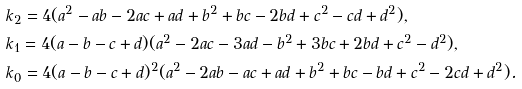Convert formula to latex. <formula><loc_0><loc_0><loc_500><loc_500>& k _ { 2 } = 4 ( a ^ { 2 } - a b - 2 a c + a d + b ^ { 2 } + b c - 2 b d + c ^ { 2 } - c d + d ^ { 2 } ) , \\ & k _ { 1 } = 4 ( a - b - c + d ) ( a ^ { 2 } - 2 a c - 3 a d - b ^ { 2 } + 3 b c + 2 b d + c ^ { 2 } - d ^ { 2 } ) , \\ & k _ { 0 } = 4 ( a - b - c + d ) ^ { 2 } ( a ^ { 2 } - 2 a b - a c + a d + b ^ { 2 } + b c - b d + c ^ { 2 } - 2 c d + d ^ { 2 } ) .</formula> 